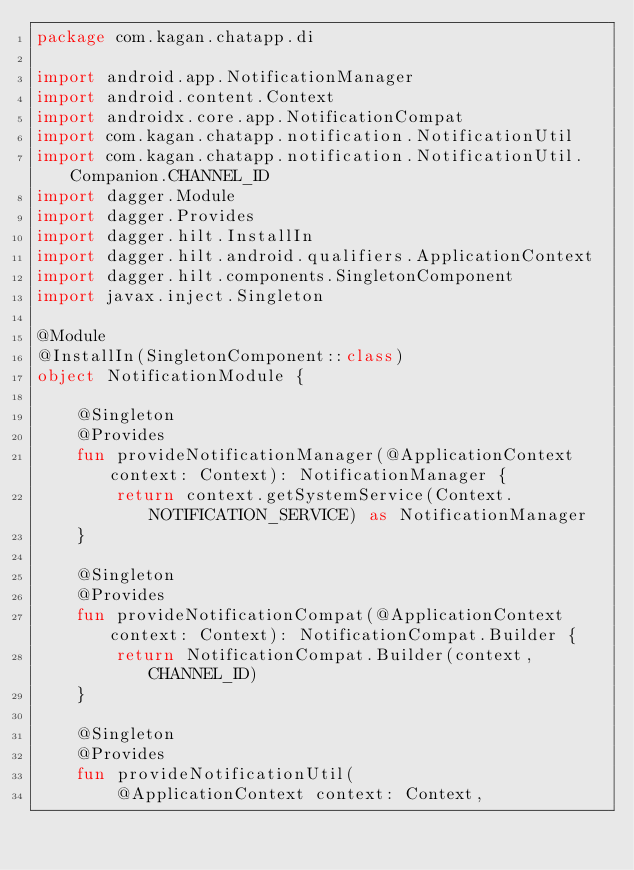<code> <loc_0><loc_0><loc_500><loc_500><_Kotlin_>package com.kagan.chatapp.di

import android.app.NotificationManager
import android.content.Context
import androidx.core.app.NotificationCompat
import com.kagan.chatapp.notification.NotificationUtil
import com.kagan.chatapp.notification.NotificationUtil.Companion.CHANNEL_ID
import dagger.Module
import dagger.Provides
import dagger.hilt.InstallIn
import dagger.hilt.android.qualifiers.ApplicationContext
import dagger.hilt.components.SingletonComponent
import javax.inject.Singleton

@Module
@InstallIn(SingletonComponent::class)
object NotificationModule {

    @Singleton
    @Provides
    fun provideNotificationManager(@ApplicationContext context: Context): NotificationManager {
        return context.getSystemService(Context.NOTIFICATION_SERVICE) as NotificationManager
    }

    @Singleton
    @Provides
    fun provideNotificationCompat(@ApplicationContext context: Context): NotificationCompat.Builder {
        return NotificationCompat.Builder(context, CHANNEL_ID)
    }

    @Singleton
    @Provides
    fun provideNotificationUtil(
        @ApplicationContext context: Context,</code> 